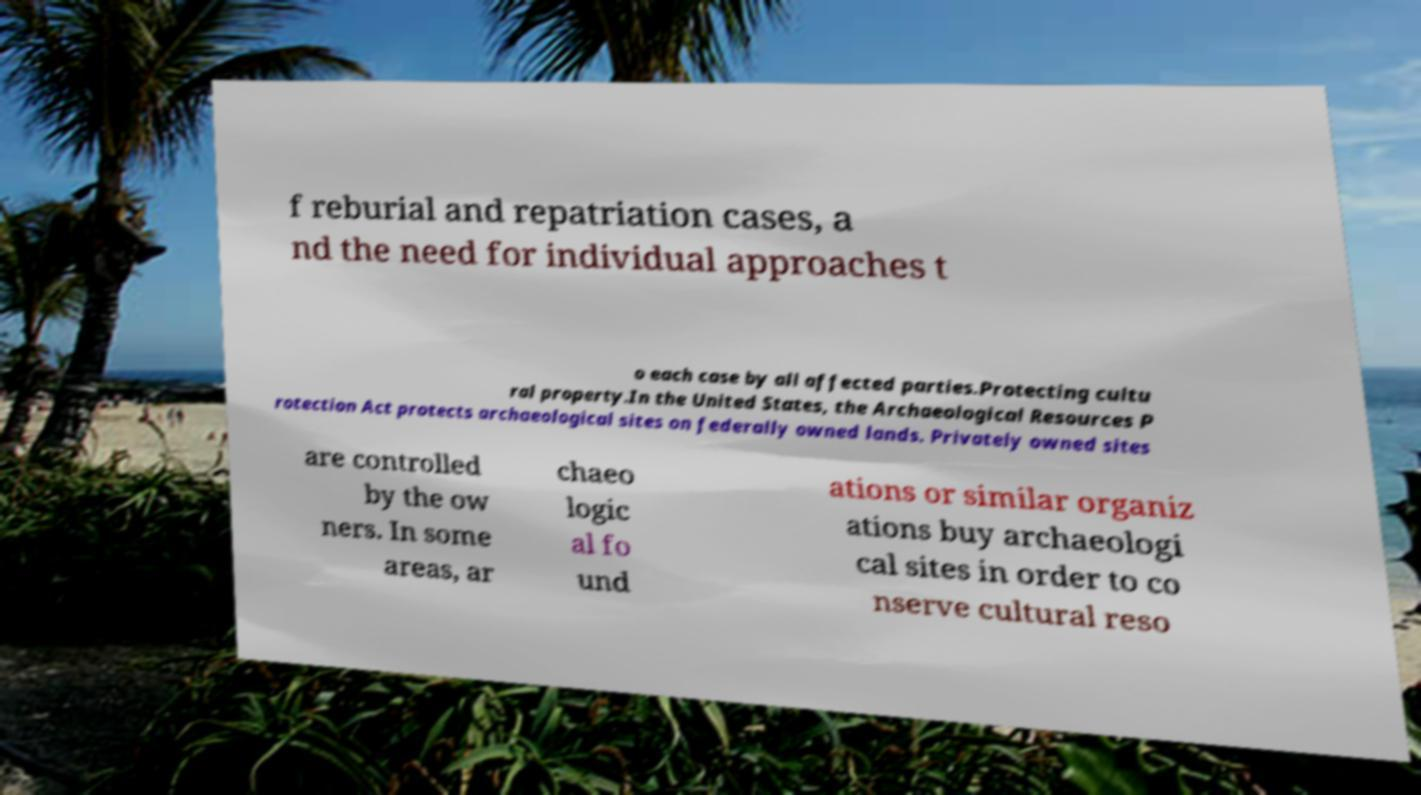Can you read and provide the text displayed in the image?This photo seems to have some interesting text. Can you extract and type it out for me? f reburial and repatriation cases, a nd the need for individual approaches t o each case by all affected parties.Protecting cultu ral property.In the United States, the Archaeological Resources P rotection Act protects archaeological sites on federally owned lands. Privately owned sites are controlled by the ow ners. In some areas, ar chaeo logic al fo und ations or similar organiz ations buy archaeologi cal sites in order to co nserve cultural reso 